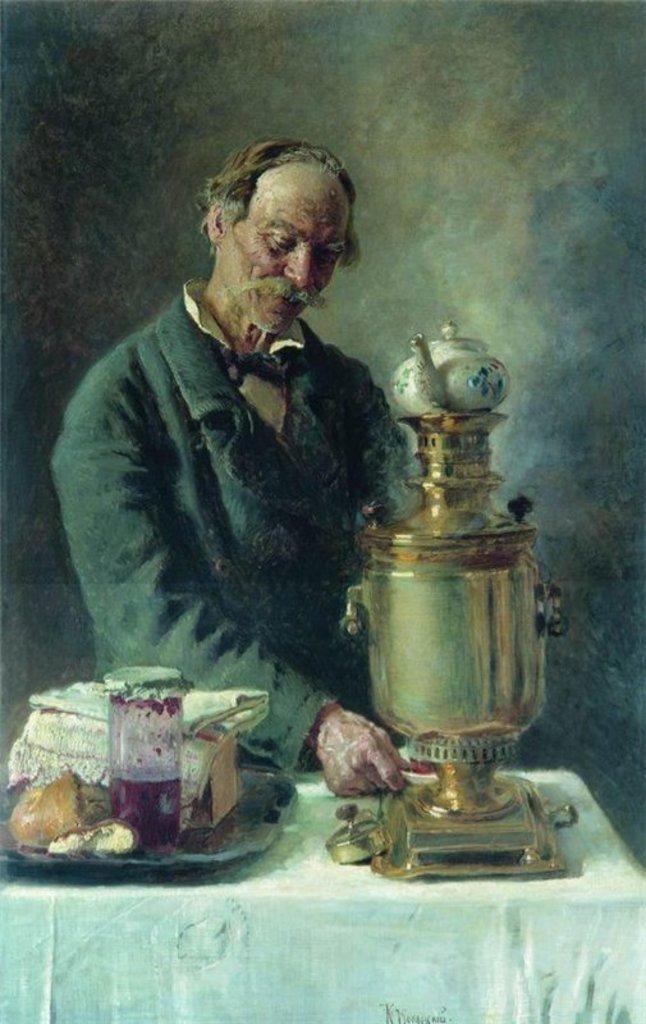Describe this image in one or two sentences. This image is looking like a painting. In this image there is a person standing in front of the table, on the table there is an object, beside that there are some food items, napkin and bottles are placed on the tray. In the background there is a wall. 